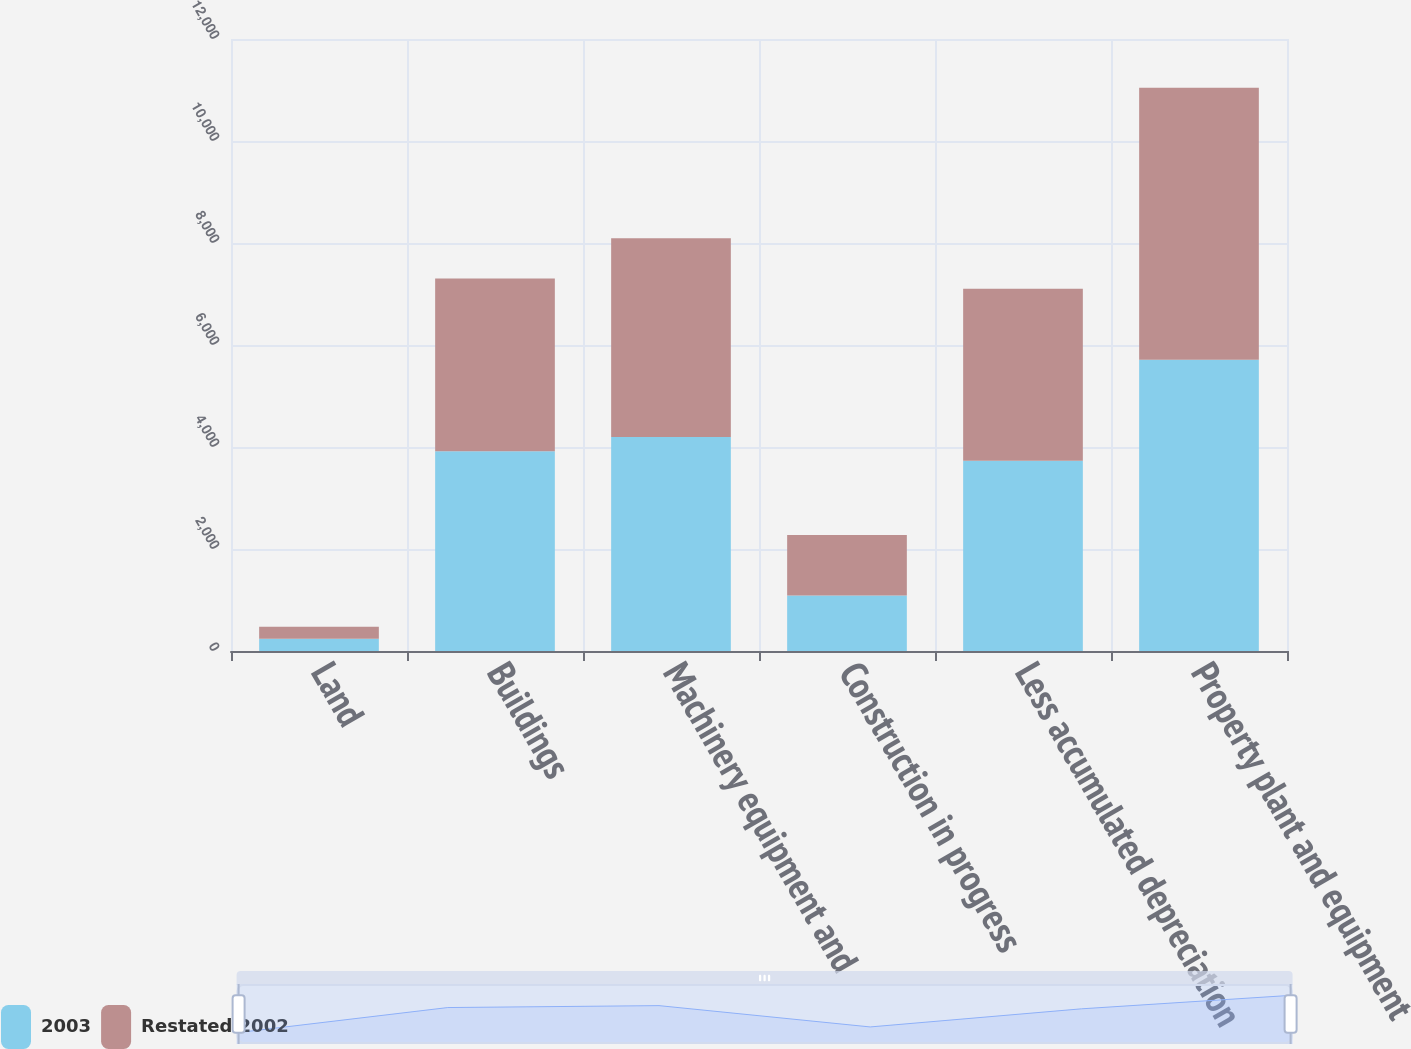Convert chart. <chart><loc_0><loc_0><loc_500><loc_500><stacked_bar_chart><ecel><fcel>Land<fcel>Buildings<fcel>Machinery equipment and<fcel>Construction in progress<fcel>Less accumulated depreciation<fcel>Property plant and equipment<nl><fcel>2003<fcel>241<fcel>3917<fcel>4197<fcel>1087<fcel>3730<fcel>5712<nl><fcel>Restated 2002<fcel>233<fcel>3389<fcel>3897<fcel>1187<fcel>3372<fcel>5334<nl></chart> 